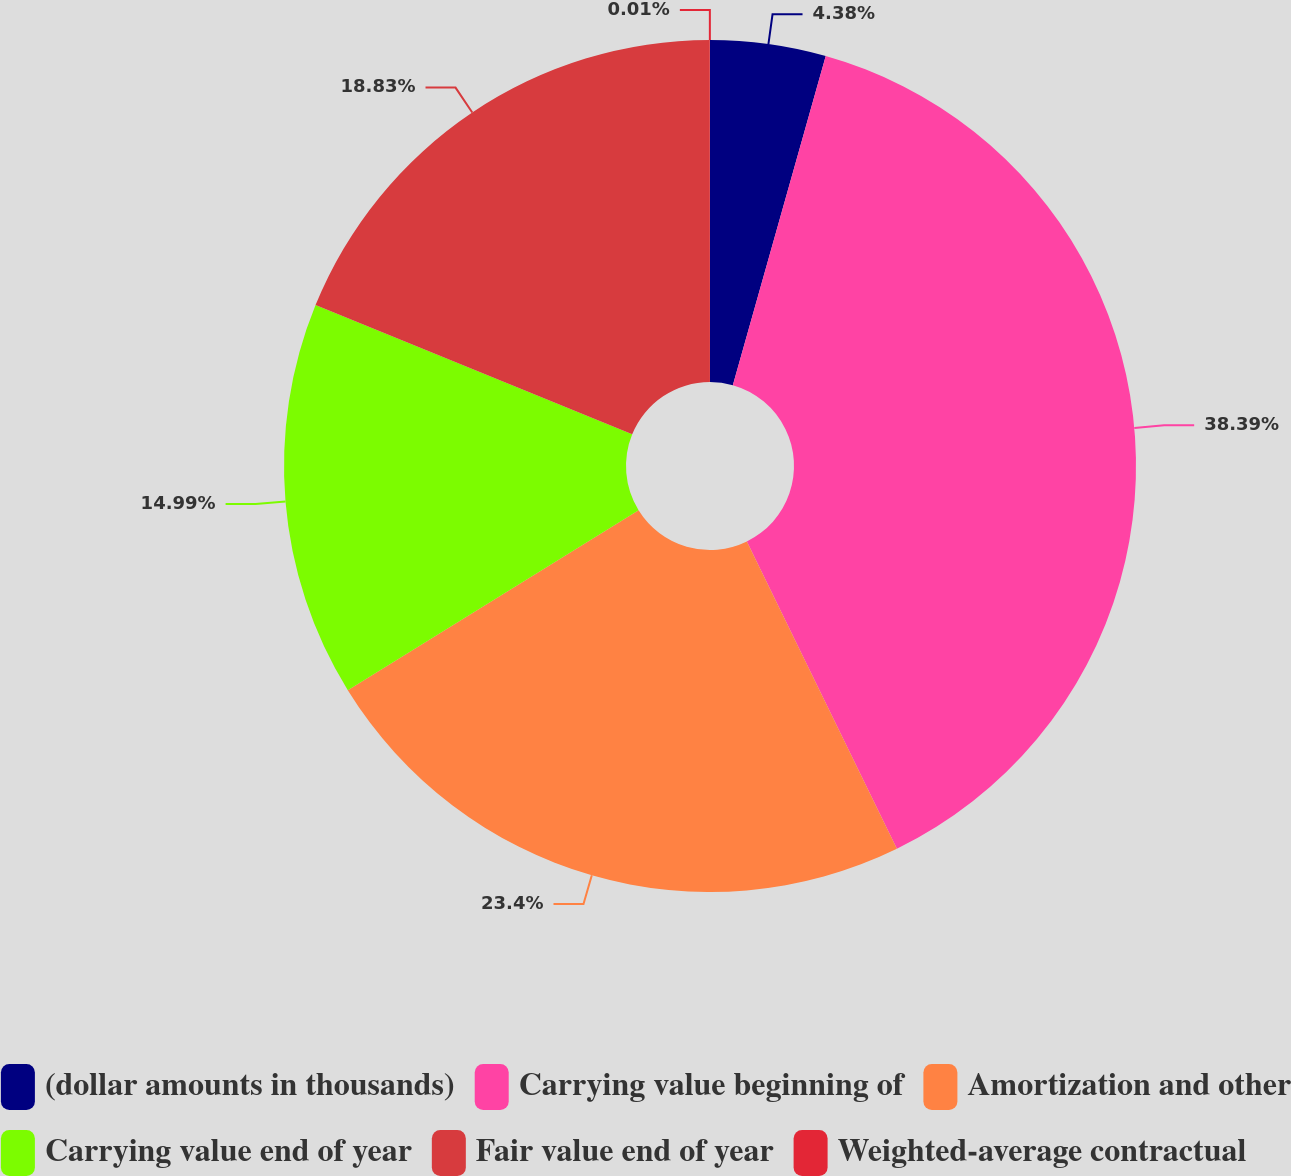<chart> <loc_0><loc_0><loc_500><loc_500><pie_chart><fcel>(dollar amounts in thousands)<fcel>Carrying value beginning of<fcel>Amortization and other<fcel>Carrying value end of year<fcel>Fair value end of year<fcel>Weighted-average contractual<nl><fcel>4.38%<fcel>38.4%<fcel>23.41%<fcel>14.99%<fcel>18.83%<fcel>0.01%<nl></chart> 